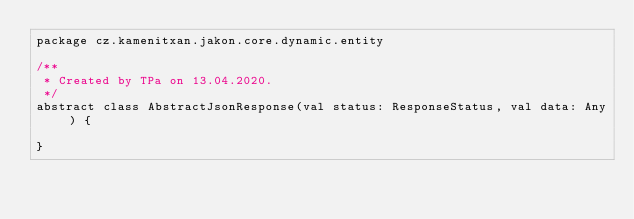<code> <loc_0><loc_0><loc_500><loc_500><_Scala_>package cz.kamenitxan.jakon.core.dynamic.entity

/**
 * Created by TPa on 13.04.2020.
 */
abstract class AbstractJsonResponse(val status: ResponseStatus, val data: Any) {

}
</code> 